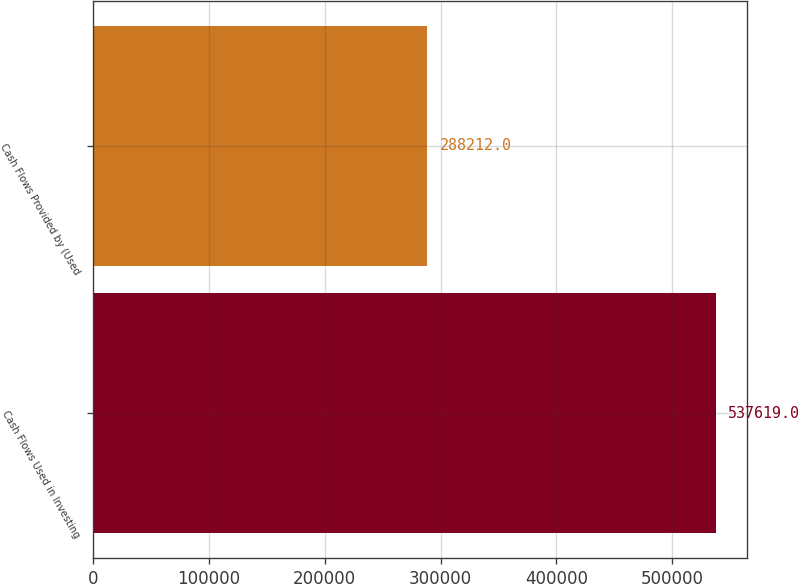Convert chart to OTSL. <chart><loc_0><loc_0><loc_500><loc_500><bar_chart><fcel>Cash Flows Used in Investing<fcel>Cash Flows Provided by (Used<nl><fcel>537619<fcel>288212<nl></chart> 